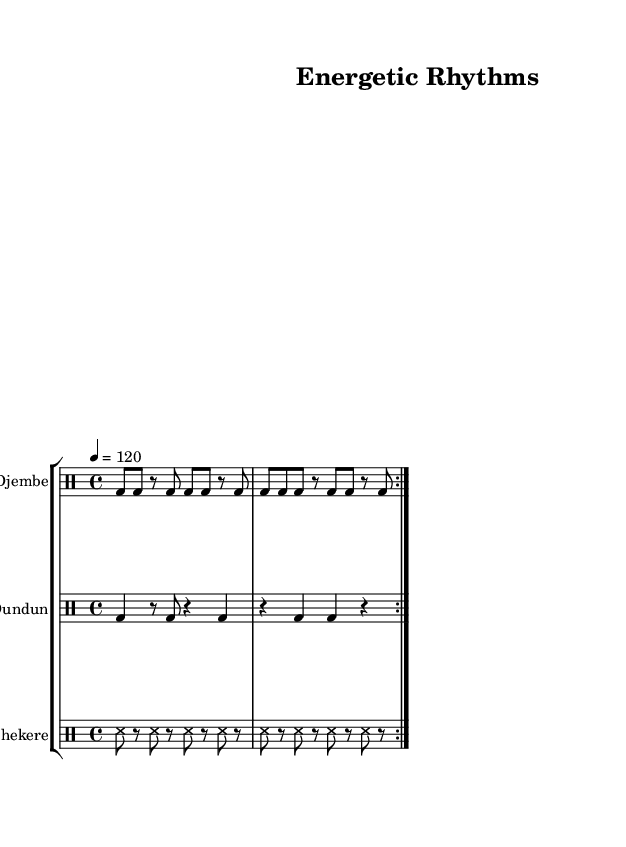What is the time signature of this music? The time signature is indicated at the beginning of the score as 4/4, meaning there are four beats in a measure and the quarter note receives one beat.
Answer: 4/4 What instrument is indicated for the first staff? The first staff is labeled "Djembe", which is a type of drum commonly used in African music.
Answer: Djembe What is the tempo marking for this piece? The tempo marking is shown as "4 = 120", which means there should be 120 beats per minute in quarter note values.
Answer: 120 How many times are the Djembe rhythms repeated? The rhythm for Djembe is marked with "volta 2", which indicates that the section should be repeated two times.
Answer: 2 What type of rhythm is used in the Shekere part? The Shekere part consists of "ss8" which stands for sixteenth notes, creating a syncopated rhythm characteristic of African drumming.
Answer: Sixteenth notes What is the rest duration in the Djembe part? The Djembe part includes "r8", which is an eighth note rest, indicating a brief pause before continuing the rhythm.
Answer: Eighth note rest How does the Dundun part differ in rhythm compared to the Djembe? The Dundun part alternates between quarter notes and rests while the Djembe has a continuous eighth note pattern, showcasing a contrasting rhythmic feel.
Answer: Contrasting rhythmic feel 